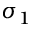<formula> <loc_0><loc_0><loc_500><loc_500>\sigma _ { 1 }</formula> 